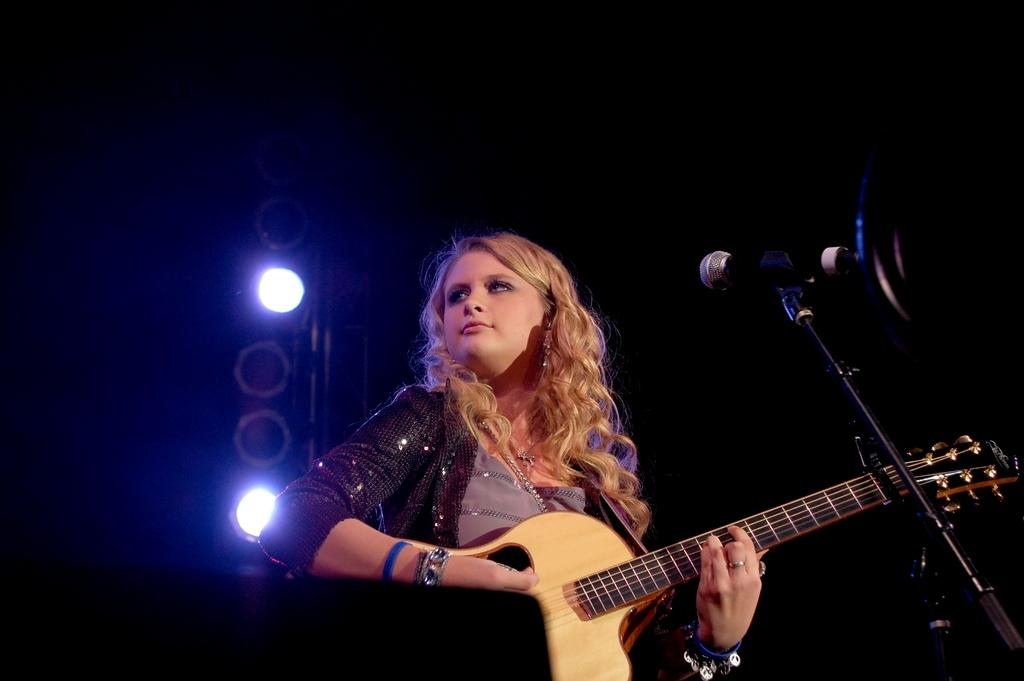Who is the main subject in the image? There is a woman in the image. What is the woman doing in the image? The woman is playing a guitar. What object is in front of the woman? The woman is in front of a microphone. What can be seen on the left side of the image? There are stage lights on the left side of the image. What day of the week is shown on the calendar in the image? There is no calendar present in the image. What level of difficulty is the woman playing the guitar at in the image? The level of difficulty cannot be determined from the image, as it only shows the woman playing the guitar. 